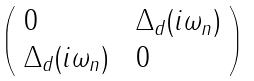<formula> <loc_0><loc_0><loc_500><loc_500>\left ( \begin{array} { l l } 0 \, & \, \Delta _ { d } ( i \omega _ { n } ) \\ \Delta _ { d } ( i \omega _ { n } ) \, & \, 0 \end{array} \right )</formula> 